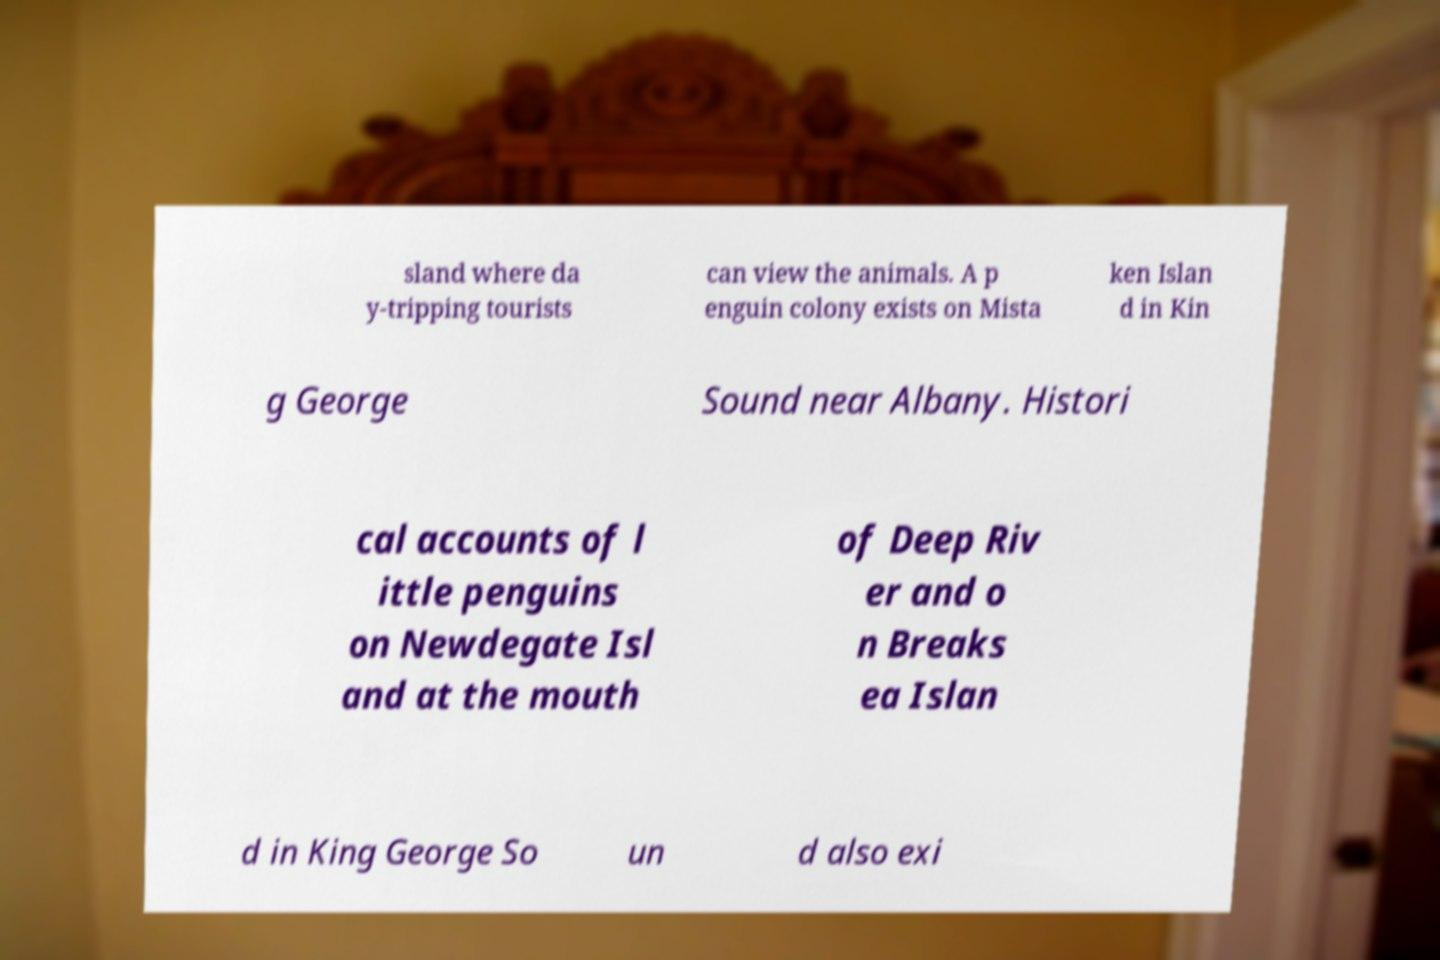Could you assist in decoding the text presented in this image and type it out clearly? sland where da y-tripping tourists can view the animals. A p enguin colony exists on Mista ken Islan d in Kin g George Sound near Albany. Histori cal accounts of l ittle penguins on Newdegate Isl and at the mouth of Deep Riv er and o n Breaks ea Islan d in King George So un d also exi 